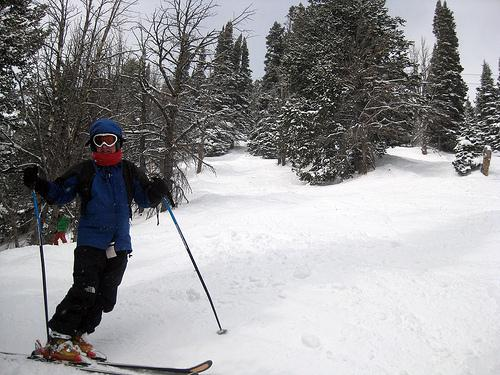Could you please give me a brief analysis of the sentiment or mood represented in the image? The image showcases a positive and adventurous mood, as the man is enjoying a skiing session amidst a beautiful snow-covered landscape. Briefly describe an interaction between two objects or elements in the image. The man is interacting with the snow on the ground by skiing down the hill, which requires skill and mastery. Can you list three items the man is wearing in the image? The man is wearing a blue coat, red scarf, and snow goggles. What color is the man's coat in the image? The man's coat is blue. Identify and describe the environment in which the man is standing in the picture. The man is standing in a snowy area with snow-covered trees, possibly on a small hill, while skiing. In a conversational style, tell me what the man in the image seems to be doing. Hey! It looks like this man is skiing down a snowy hill while holding ski poles. He's all geared up to embrace the cold! Estimate the total number of objects detected in the image, including trees and man's accessories. There are at least 26 objects detected, including trees, ski poles, and various clothing items. Mention the two primary colors of the items the man is wearing in the image and provide examples of these items. The primary colors are blue and red. Examples include the blue coat and hat, and the red scarf. What sport does the man in the image appear to be participating in, and what gear is he using? The man appears to be participating in skiing, and he's using ski poles and skis as his gear. How many trees with snow on them are present in the image? There are seven trees with snow on them. 